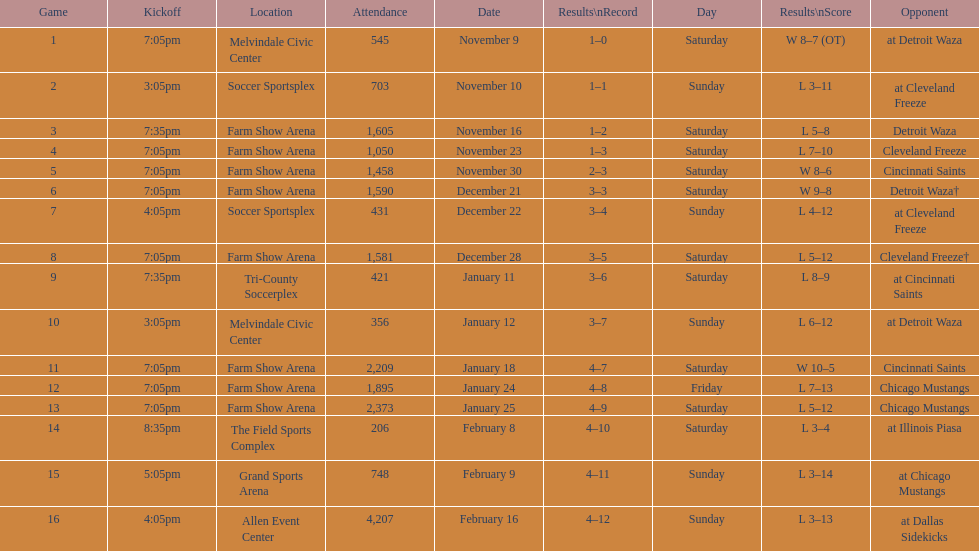Which rival is mentioned first in the table? Detroit Waza. 